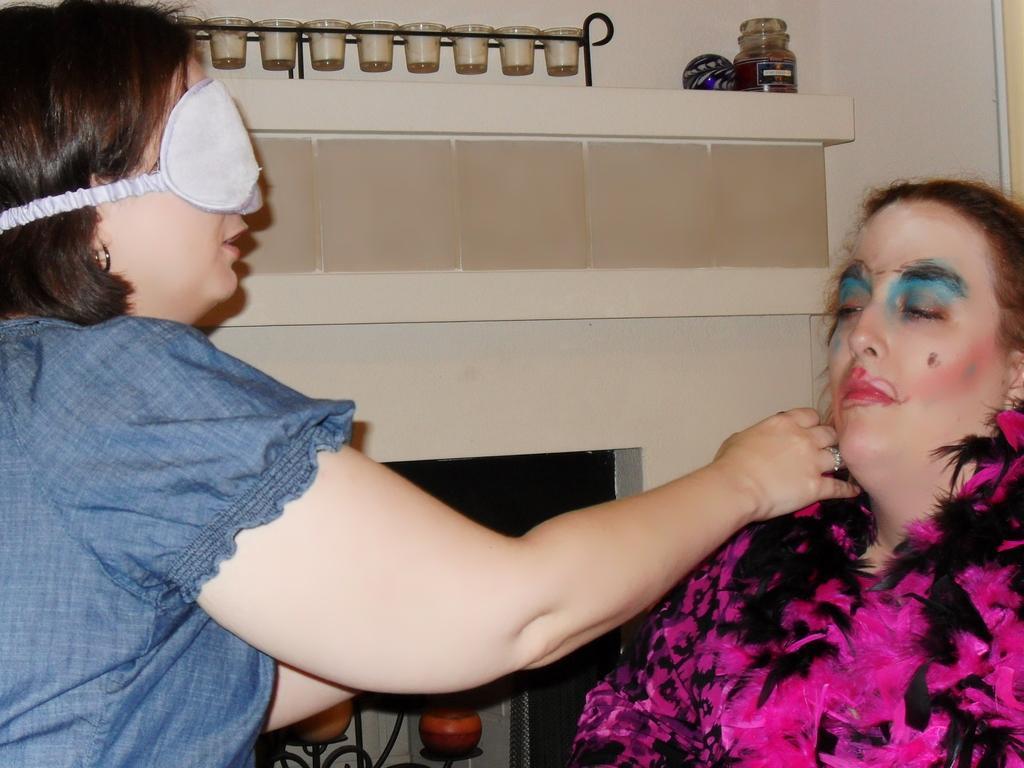Could you give a brief overview of what you see in this image? In this picture we can see two women, on the left side of the given image we can see a woman, she wore a blindfold, beside to them we can see a bottle and other things. 